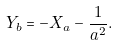<formula> <loc_0><loc_0><loc_500><loc_500>Y _ { b } = - X _ { a } - \frac { 1 } { a ^ { 2 } } .</formula> 